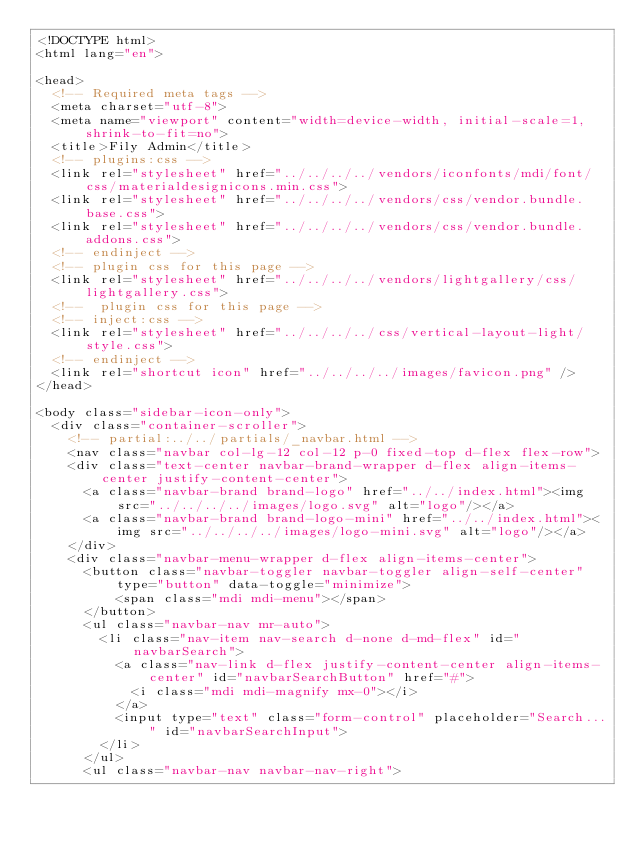<code> <loc_0><loc_0><loc_500><loc_500><_HTML_><!DOCTYPE html>
<html lang="en">

<head>
  <!-- Required meta tags -->
  <meta charset="utf-8">
  <meta name="viewport" content="width=device-width, initial-scale=1, shrink-to-fit=no">
  <title>Fily Admin</title>
  <!-- plugins:css -->
  <link rel="stylesheet" href="../../../../vendors/iconfonts/mdi/font/css/materialdesignicons.min.css">
  <link rel="stylesheet" href="../../../../vendors/css/vendor.bundle.base.css">
  <link rel="stylesheet" href="../../../../vendors/css/vendor.bundle.addons.css">
  <!-- endinject -->
  <!-- plugin css for this page -->
  <link rel="stylesheet" href="../../../../vendors/lightgallery/css/lightgallery.css">
  <!--  plugin css for this page -->
  <!-- inject:css -->
  <link rel="stylesheet" href="../../../../css/vertical-layout-light/style.css">
  <!-- endinject -->
  <link rel="shortcut icon" href="../../../../images/favicon.png" />
</head>

<body class="sidebar-icon-only">
  <div class="container-scroller">
    <!-- partial:../../partials/_navbar.html -->
    <nav class="navbar col-lg-12 col-12 p-0 fixed-top d-flex flex-row">
    <div class="text-center navbar-brand-wrapper d-flex align-items-center justify-content-center">
      <a class="navbar-brand brand-logo" href="../../index.html"><img src="../../../../images/logo.svg" alt="logo"/></a>
      <a class="navbar-brand brand-logo-mini" href="../../index.html"><img src="../../../../images/logo-mini.svg" alt="logo"/></a>
    </div>
    <div class="navbar-menu-wrapper d-flex align-items-center">
      <button class="navbar-toggler navbar-toggler align-self-center" type="button" data-toggle="minimize">
          <span class="mdi mdi-menu"></span>
      </button>
      <ul class="navbar-nav mr-auto">
        <li class="nav-item nav-search d-none d-md-flex" id="navbarSearch">
          <a class="nav-link d-flex justify-content-center align-items-center" id="navbarSearchButton" href="#">
            <i class="mdi mdi-magnify mx-0"></i>
          </a>
          <input type="text" class="form-control" placeholder="Search..." id="navbarSearchInput">                
        </li>
      </ul>    
      <ul class="navbar-nav navbar-nav-right"></code> 